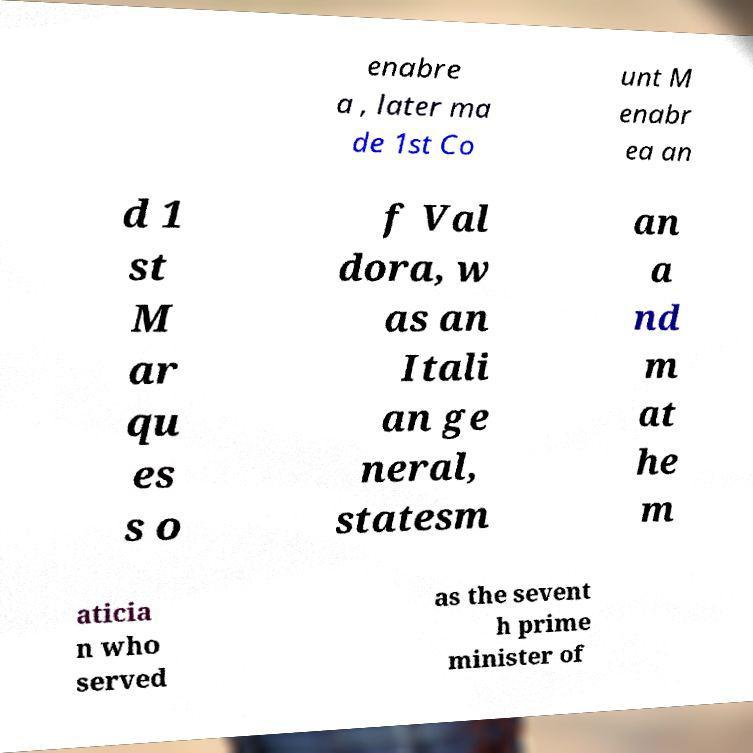Could you assist in decoding the text presented in this image and type it out clearly? enabre a , later ma de 1st Co unt M enabr ea an d 1 st M ar qu es s o f Val dora, w as an Itali an ge neral, statesm an a nd m at he m aticia n who served as the sevent h prime minister of 